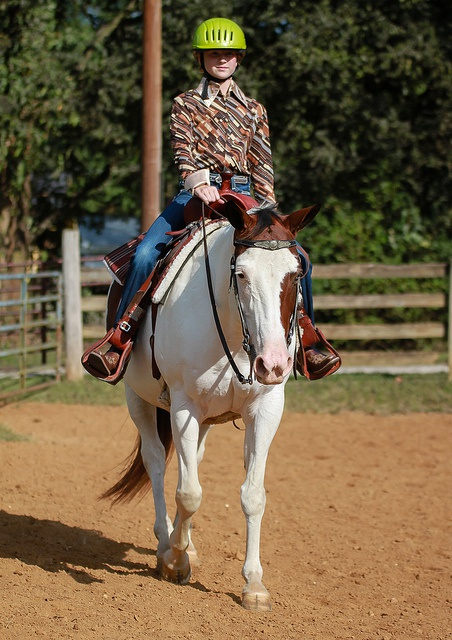Describe the objects in this image and their specific colors. I can see horse in black, gray, lightgray, and darkgray tones and people in black, maroon, brown, and gray tones in this image. 